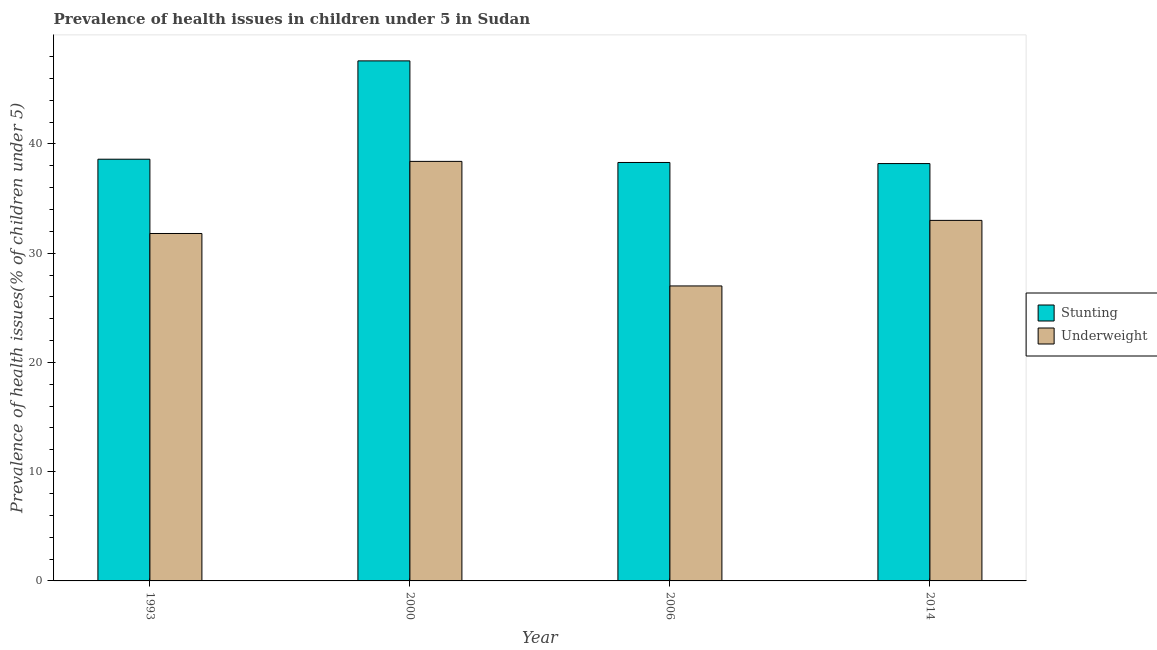How many different coloured bars are there?
Your answer should be compact. 2. Are the number of bars per tick equal to the number of legend labels?
Offer a terse response. Yes. Are the number of bars on each tick of the X-axis equal?
Your answer should be very brief. Yes. How many bars are there on the 2nd tick from the left?
Give a very brief answer. 2. How many bars are there on the 3rd tick from the right?
Your answer should be compact. 2. In how many cases, is the number of bars for a given year not equal to the number of legend labels?
Provide a succinct answer. 0. What is the percentage of stunted children in 2006?
Your answer should be compact. 38.3. Across all years, what is the maximum percentage of stunted children?
Keep it short and to the point. 47.6. Across all years, what is the minimum percentage of stunted children?
Your response must be concise. 38.2. In which year was the percentage of underweight children minimum?
Give a very brief answer. 2006. What is the total percentage of stunted children in the graph?
Ensure brevity in your answer.  162.7. What is the difference between the percentage of underweight children in 1993 and that in 2014?
Keep it short and to the point. -1.2. What is the difference between the percentage of underweight children in 2006 and the percentage of stunted children in 1993?
Give a very brief answer. -4.8. What is the average percentage of underweight children per year?
Ensure brevity in your answer.  32.55. What is the ratio of the percentage of stunted children in 1993 to that in 2000?
Ensure brevity in your answer.  0.81. Is the percentage of stunted children in 1993 less than that in 2000?
Keep it short and to the point. Yes. What is the difference between the highest and the lowest percentage of stunted children?
Provide a short and direct response. 9.4. Is the sum of the percentage of underweight children in 1993 and 2000 greater than the maximum percentage of stunted children across all years?
Keep it short and to the point. Yes. What does the 2nd bar from the left in 2000 represents?
Give a very brief answer. Underweight. What does the 1st bar from the right in 2006 represents?
Offer a terse response. Underweight. How many bars are there?
Your answer should be compact. 8. How many years are there in the graph?
Your response must be concise. 4. Does the graph contain any zero values?
Provide a succinct answer. No. Does the graph contain grids?
Make the answer very short. No. Where does the legend appear in the graph?
Keep it short and to the point. Center right. How many legend labels are there?
Make the answer very short. 2. How are the legend labels stacked?
Your answer should be compact. Vertical. What is the title of the graph?
Keep it short and to the point. Prevalence of health issues in children under 5 in Sudan. What is the label or title of the Y-axis?
Offer a terse response. Prevalence of health issues(% of children under 5). What is the Prevalence of health issues(% of children under 5) of Stunting in 1993?
Your response must be concise. 38.6. What is the Prevalence of health issues(% of children under 5) of Underweight in 1993?
Ensure brevity in your answer.  31.8. What is the Prevalence of health issues(% of children under 5) of Stunting in 2000?
Keep it short and to the point. 47.6. What is the Prevalence of health issues(% of children under 5) of Underweight in 2000?
Offer a very short reply. 38.4. What is the Prevalence of health issues(% of children under 5) in Stunting in 2006?
Offer a very short reply. 38.3. What is the Prevalence of health issues(% of children under 5) in Underweight in 2006?
Provide a succinct answer. 27. What is the Prevalence of health issues(% of children under 5) of Stunting in 2014?
Provide a short and direct response. 38.2. What is the Prevalence of health issues(% of children under 5) of Underweight in 2014?
Ensure brevity in your answer.  33. Across all years, what is the maximum Prevalence of health issues(% of children under 5) of Stunting?
Offer a very short reply. 47.6. Across all years, what is the maximum Prevalence of health issues(% of children under 5) in Underweight?
Your response must be concise. 38.4. Across all years, what is the minimum Prevalence of health issues(% of children under 5) in Stunting?
Give a very brief answer. 38.2. Across all years, what is the minimum Prevalence of health issues(% of children under 5) of Underweight?
Give a very brief answer. 27. What is the total Prevalence of health issues(% of children under 5) of Stunting in the graph?
Provide a succinct answer. 162.7. What is the total Prevalence of health issues(% of children under 5) of Underweight in the graph?
Offer a terse response. 130.2. What is the difference between the Prevalence of health issues(% of children under 5) of Underweight in 1993 and that in 2014?
Your answer should be compact. -1.2. What is the difference between the Prevalence of health issues(% of children under 5) of Stunting in 2000 and that in 2014?
Provide a short and direct response. 9.4. What is the difference between the Prevalence of health issues(% of children under 5) in Underweight in 2000 and that in 2014?
Provide a succinct answer. 5.4. What is the difference between the Prevalence of health issues(% of children under 5) in Stunting in 2006 and that in 2014?
Provide a short and direct response. 0.1. What is the difference between the Prevalence of health issues(% of children under 5) of Stunting in 1993 and the Prevalence of health issues(% of children under 5) of Underweight in 2000?
Your answer should be compact. 0.2. What is the difference between the Prevalence of health issues(% of children under 5) in Stunting in 2000 and the Prevalence of health issues(% of children under 5) in Underweight in 2006?
Provide a succinct answer. 20.6. What is the difference between the Prevalence of health issues(% of children under 5) of Stunting in 2000 and the Prevalence of health issues(% of children under 5) of Underweight in 2014?
Give a very brief answer. 14.6. What is the average Prevalence of health issues(% of children under 5) of Stunting per year?
Ensure brevity in your answer.  40.67. What is the average Prevalence of health issues(% of children under 5) of Underweight per year?
Ensure brevity in your answer.  32.55. In the year 1993, what is the difference between the Prevalence of health issues(% of children under 5) in Stunting and Prevalence of health issues(% of children under 5) in Underweight?
Offer a very short reply. 6.8. In the year 2000, what is the difference between the Prevalence of health issues(% of children under 5) of Stunting and Prevalence of health issues(% of children under 5) of Underweight?
Make the answer very short. 9.2. What is the ratio of the Prevalence of health issues(% of children under 5) of Stunting in 1993 to that in 2000?
Offer a very short reply. 0.81. What is the ratio of the Prevalence of health issues(% of children under 5) in Underweight in 1993 to that in 2000?
Offer a terse response. 0.83. What is the ratio of the Prevalence of health issues(% of children under 5) in Stunting in 1993 to that in 2006?
Your answer should be compact. 1.01. What is the ratio of the Prevalence of health issues(% of children under 5) of Underweight in 1993 to that in 2006?
Provide a short and direct response. 1.18. What is the ratio of the Prevalence of health issues(% of children under 5) in Stunting in 1993 to that in 2014?
Give a very brief answer. 1.01. What is the ratio of the Prevalence of health issues(% of children under 5) in Underweight in 1993 to that in 2014?
Offer a very short reply. 0.96. What is the ratio of the Prevalence of health issues(% of children under 5) in Stunting in 2000 to that in 2006?
Make the answer very short. 1.24. What is the ratio of the Prevalence of health issues(% of children under 5) in Underweight in 2000 to that in 2006?
Keep it short and to the point. 1.42. What is the ratio of the Prevalence of health issues(% of children under 5) in Stunting in 2000 to that in 2014?
Your answer should be very brief. 1.25. What is the ratio of the Prevalence of health issues(% of children under 5) of Underweight in 2000 to that in 2014?
Your answer should be very brief. 1.16. What is the ratio of the Prevalence of health issues(% of children under 5) in Stunting in 2006 to that in 2014?
Offer a very short reply. 1. What is the ratio of the Prevalence of health issues(% of children under 5) in Underweight in 2006 to that in 2014?
Keep it short and to the point. 0.82. What is the difference between the highest and the second highest Prevalence of health issues(% of children under 5) of Stunting?
Offer a very short reply. 9. What is the difference between the highest and the second highest Prevalence of health issues(% of children under 5) of Underweight?
Keep it short and to the point. 5.4. What is the difference between the highest and the lowest Prevalence of health issues(% of children under 5) of Underweight?
Your answer should be compact. 11.4. 